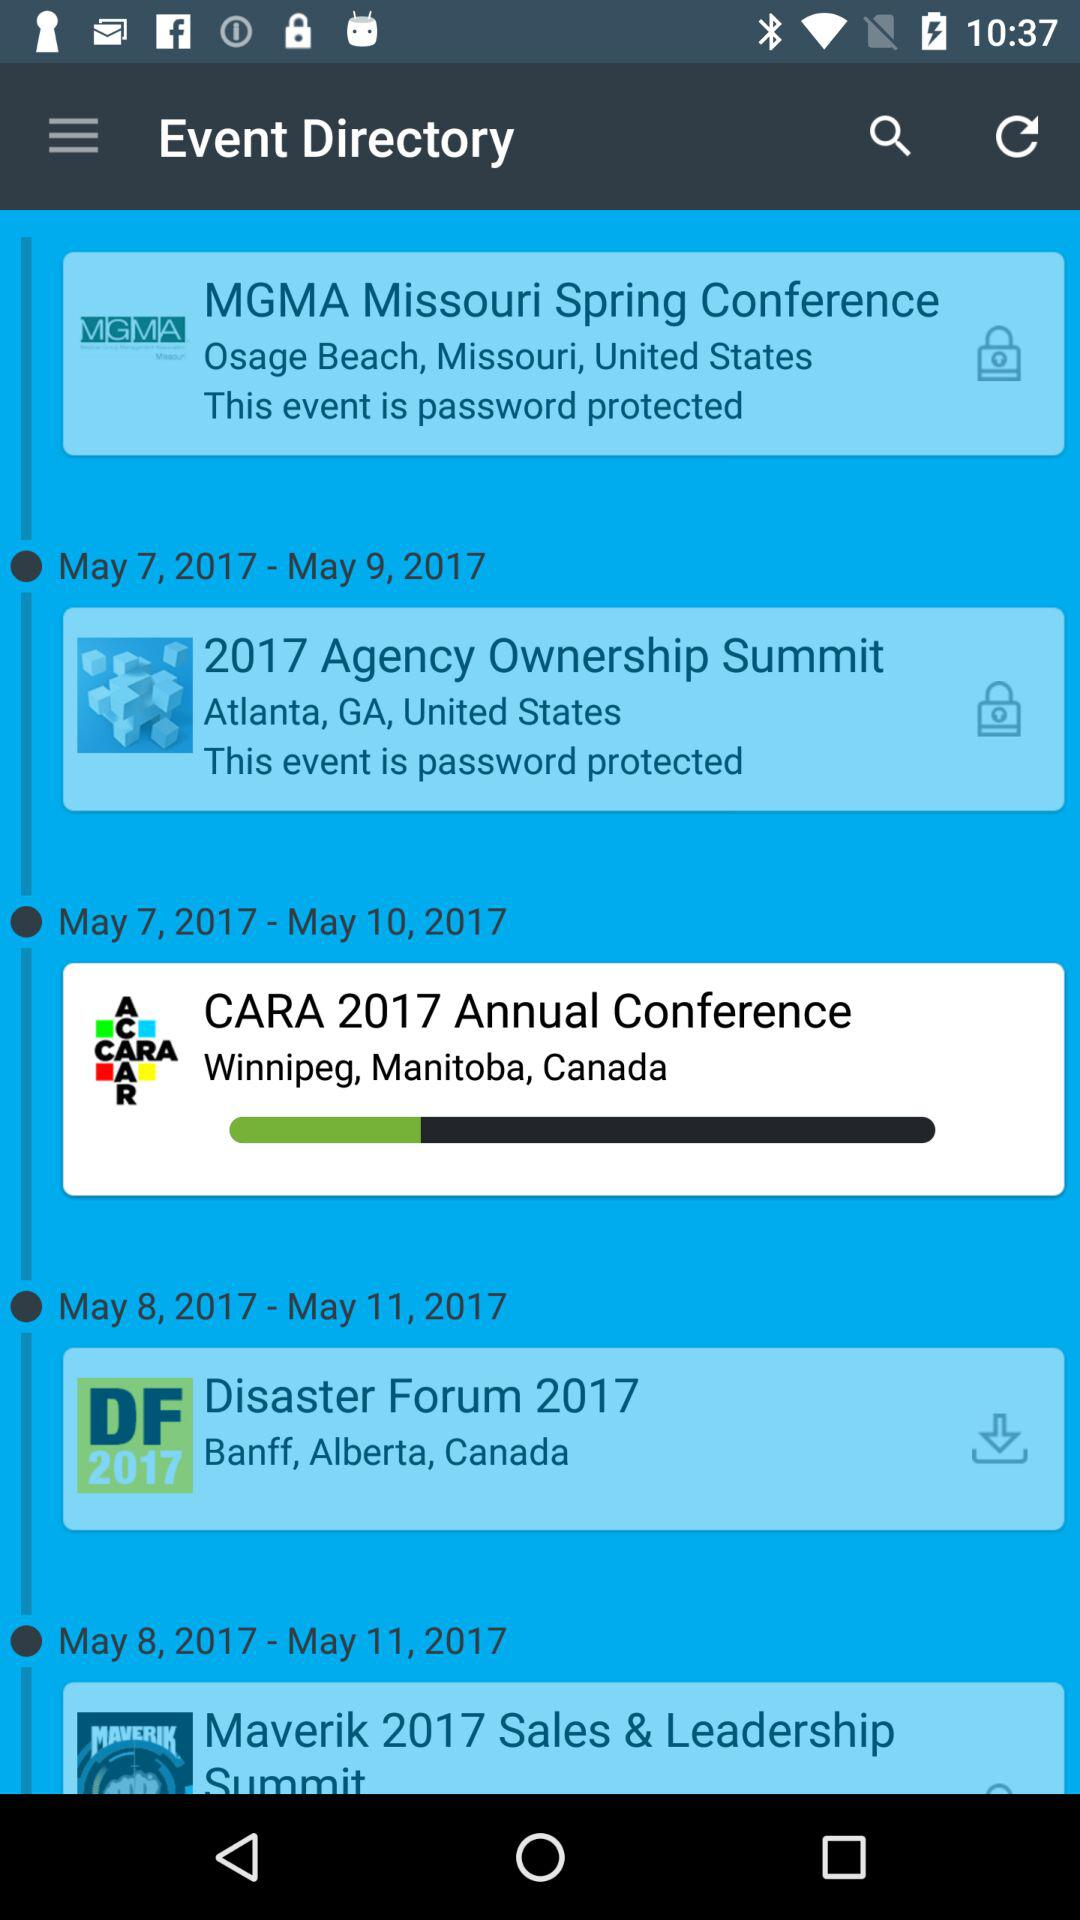What is the duration of the event named "Disaster Forum 2017"? The duration of the event named "Disaster Forum 2017" is from May 8, 2017 to May 11, 2017. 